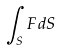Convert formula to latex. <formula><loc_0><loc_0><loc_500><loc_500>\int _ { S } F d S</formula> 